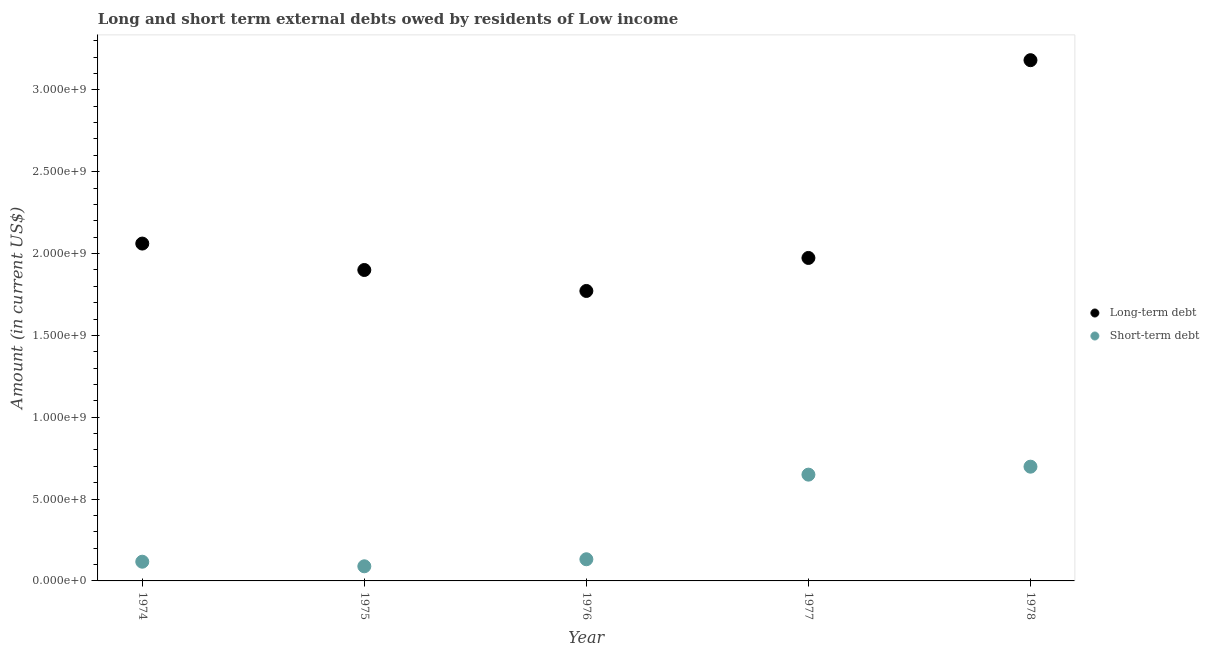How many different coloured dotlines are there?
Make the answer very short. 2. What is the long-term debts owed by residents in 1977?
Offer a terse response. 1.97e+09. Across all years, what is the maximum short-term debts owed by residents?
Your response must be concise. 6.98e+08. Across all years, what is the minimum short-term debts owed by residents?
Your answer should be very brief. 8.94e+07. In which year was the short-term debts owed by residents maximum?
Give a very brief answer. 1978. In which year was the long-term debts owed by residents minimum?
Give a very brief answer. 1976. What is the total short-term debts owed by residents in the graph?
Provide a short and direct response. 1.69e+09. What is the difference between the long-term debts owed by residents in 1976 and that in 1978?
Your answer should be compact. -1.41e+09. What is the difference between the long-term debts owed by residents in 1975 and the short-term debts owed by residents in 1977?
Your answer should be compact. 1.25e+09. What is the average short-term debts owed by residents per year?
Provide a succinct answer. 3.37e+08. In the year 1978, what is the difference between the long-term debts owed by residents and short-term debts owed by residents?
Make the answer very short. 2.48e+09. What is the ratio of the long-term debts owed by residents in 1974 to that in 1975?
Ensure brevity in your answer.  1.08. Is the short-term debts owed by residents in 1974 less than that in 1977?
Ensure brevity in your answer.  Yes. What is the difference between the highest and the second highest short-term debts owed by residents?
Make the answer very short. 4.86e+07. What is the difference between the highest and the lowest short-term debts owed by residents?
Ensure brevity in your answer.  6.09e+08. In how many years, is the short-term debts owed by residents greater than the average short-term debts owed by residents taken over all years?
Ensure brevity in your answer.  2. Is the short-term debts owed by residents strictly greater than the long-term debts owed by residents over the years?
Give a very brief answer. No. How many dotlines are there?
Offer a terse response. 2. How many years are there in the graph?
Offer a very short reply. 5. What is the difference between two consecutive major ticks on the Y-axis?
Your answer should be compact. 5.00e+08. Does the graph contain any zero values?
Offer a terse response. No. Does the graph contain grids?
Keep it short and to the point. No. How many legend labels are there?
Ensure brevity in your answer.  2. How are the legend labels stacked?
Make the answer very short. Vertical. What is the title of the graph?
Make the answer very short. Long and short term external debts owed by residents of Low income. Does "Net savings(excluding particulate emission damage)" appear as one of the legend labels in the graph?
Your answer should be very brief. No. What is the label or title of the Y-axis?
Offer a terse response. Amount (in current US$). What is the Amount (in current US$) of Long-term debt in 1974?
Keep it short and to the point. 2.06e+09. What is the Amount (in current US$) of Short-term debt in 1974?
Make the answer very short. 1.17e+08. What is the Amount (in current US$) of Long-term debt in 1975?
Your response must be concise. 1.90e+09. What is the Amount (in current US$) in Short-term debt in 1975?
Offer a very short reply. 8.94e+07. What is the Amount (in current US$) of Long-term debt in 1976?
Your response must be concise. 1.77e+09. What is the Amount (in current US$) of Short-term debt in 1976?
Provide a short and direct response. 1.32e+08. What is the Amount (in current US$) in Long-term debt in 1977?
Your answer should be very brief. 1.97e+09. What is the Amount (in current US$) in Short-term debt in 1977?
Offer a very short reply. 6.49e+08. What is the Amount (in current US$) of Long-term debt in 1978?
Your answer should be very brief. 3.18e+09. What is the Amount (in current US$) in Short-term debt in 1978?
Offer a very short reply. 6.98e+08. Across all years, what is the maximum Amount (in current US$) of Long-term debt?
Ensure brevity in your answer.  3.18e+09. Across all years, what is the maximum Amount (in current US$) in Short-term debt?
Offer a terse response. 6.98e+08. Across all years, what is the minimum Amount (in current US$) of Long-term debt?
Provide a short and direct response. 1.77e+09. Across all years, what is the minimum Amount (in current US$) in Short-term debt?
Keep it short and to the point. 8.94e+07. What is the total Amount (in current US$) in Long-term debt in the graph?
Keep it short and to the point. 1.09e+1. What is the total Amount (in current US$) in Short-term debt in the graph?
Make the answer very short. 1.69e+09. What is the difference between the Amount (in current US$) in Long-term debt in 1974 and that in 1975?
Make the answer very short. 1.61e+08. What is the difference between the Amount (in current US$) of Short-term debt in 1974 and that in 1975?
Provide a succinct answer. 2.80e+07. What is the difference between the Amount (in current US$) of Long-term debt in 1974 and that in 1976?
Your answer should be very brief. 2.90e+08. What is the difference between the Amount (in current US$) of Short-term debt in 1974 and that in 1976?
Ensure brevity in your answer.  -1.50e+07. What is the difference between the Amount (in current US$) in Long-term debt in 1974 and that in 1977?
Ensure brevity in your answer.  8.79e+07. What is the difference between the Amount (in current US$) of Short-term debt in 1974 and that in 1977?
Provide a short and direct response. -5.32e+08. What is the difference between the Amount (in current US$) of Long-term debt in 1974 and that in 1978?
Give a very brief answer. -1.12e+09. What is the difference between the Amount (in current US$) in Short-term debt in 1974 and that in 1978?
Keep it short and to the point. -5.81e+08. What is the difference between the Amount (in current US$) of Long-term debt in 1975 and that in 1976?
Your response must be concise. 1.28e+08. What is the difference between the Amount (in current US$) of Short-term debt in 1975 and that in 1976?
Your answer should be very brief. -4.30e+07. What is the difference between the Amount (in current US$) of Long-term debt in 1975 and that in 1977?
Your answer should be very brief. -7.36e+07. What is the difference between the Amount (in current US$) of Short-term debt in 1975 and that in 1977?
Provide a succinct answer. -5.60e+08. What is the difference between the Amount (in current US$) of Long-term debt in 1975 and that in 1978?
Ensure brevity in your answer.  -1.28e+09. What is the difference between the Amount (in current US$) in Short-term debt in 1975 and that in 1978?
Offer a terse response. -6.09e+08. What is the difference between the Amount (in current US$) of Long-term debt in 1976 and that in 1977?
Offer a very short reply. -2.02e+08. What is the difference between the Amount (in current US$) of Short-term debt in 1976 and that in 1977?
Keep it short and to the point. -5.17e+08. What is the difference between the Amount (in current US$) in Long-term debt in 1976 and that in 1978?
Make the answer very short. -1.41e+09. What is the difference between the Amount (in current US$) of Short-term debt in 1976 and that in 1978?
Provide a succinct answer. -5.66e+08. What is the difference between the Amount (in current US$) in Long-term debt in 1977 and that in 1978?
Keep it short and to the point. -1.21e+09. What is the difference between the Amount (in current US$) of Short-term debt in 1977 and that in 1978?
Offer a terse response. -4.86e+07. What is the difference between the Amount (in current US$) in Long-term debt in 1974 and the Amount (in current US$) in Short-term debt in 1975?
Offer a very short reply. 1.97e+09. What is the difference between the Amount (in current US$) in Long-term debt in 1974 and the Amount (in current US$) in Short-term debt in 1976?
Offer a very short reply. 1.93e+09. What is the difference between the Amount (in current US$) of Long-term debt in 1974 and the Amount (in current US$) of Short-term debt in 1977?
Your response must be concise. 1.41e+09. What is the difference between the Amount (in current US$) of Long-term debt in 1974 and the Amount (in current US$) of Short-term debt in 1978?
Offer a terse response. 1.36e+09. What is the difference between the Amount (in current US$) in Long-term debt in 1975 and the Amount (in current US$) in Short-term debt in 1976?
Offer a very short reply. 1.77e+09. What is the difference between the Amount (in current US$) in Long-term debt in 1975 and the Amount (in current US$) in Short-term debt in 1977?
Your answer should be compact. 1.25e+09. What is the difference between the Amount (in current US$) of Long-term debt in 1975 and the Amount (in current US$) of Short-term debt in 1978?
Ensure brevity in your answer.  1.20e+09. What is the difference between the Amount (in current US$) of Long-term debt in 1976 and the Amount (in current US$) of Short-term debt in 1977?
Give a very brief answer. 1.12e+09. What is the difference between the Amount (in current US$) of Long-term debt in 1976 and the Amount (in current US$) of Short-term debt in 1978?
Provide a short and direct response. 1.07e+09. What is the difference between the Amount (in current US$) of Long-term debt in 1977 and the Amount (in current US$) of Short-term debt in 1978?
Ensure brevity in your answer.  1.28e+09. What is the average Amount (in current US$) in Long-term debt per year?
Give a very brief answer. 2.18e+09. What is the average Amount (in current US$) in Short-term debt per year?
Offer a terse response. 3.37e+08. In the year 1974, what is the difference between the Amount (in current US$) in Long-term debt and Amount (in current US$) in Short-term debt?
Your answer should be compact. 1.94e+09. In the year 1975, what is the difference between the Amount (in current US$) in Long-term debt and Amount (in current US$) in Short-term debt?
Your answer should be compact. 1.81e+09. In the year 1976, what is the difference between the Amount (in current US$) of Long-term debt and Amount (in current US$) of Short-term debt?
Make the answer very short. 1.64e+09. In the year 1977, what is the difference between the Amount (in current US$) of Long-term debt and Amount (in current US$) of Short-term debt?
Make the answer very short. 1.32e+09. In the year 1978, what is the difference between the Amount (in current US$) of Long-term debt and Amount (in current US$) of Short-term debt?
Keep it short and to the point. 2.48e+09. What is the ratio of the Amount (in current US$) in Long-term debt in 1974 to that in 1975?
Your response must be concise. 1.08. What is the ratio of the Amount (in current US$) in Short-term debt in 1974 to that in 1975?
Offer a terse response. 1.31. What is the ratio of the Amount (in current US$) in Long-term debt in 1974 to that in 1976?
Ensure brevity in your answer.  1.16. What is the ratio of the Amount (in current US$) in Short-term debt in 1974 to that in 1976?
Provide a succinct answer. 0.89. What is the ratio of the Amount (in current US$) in Long-term debt in 1974 to that in 1977?
Offer a very short reply. 1.04. What is the ratio of the Amount (in current US$) of Short-term debt in 1974 to that in 1977?
Your answer should be compact. 0.18. What is the ratio of the Amount (in current US$) in Long-term debt in 1974 to that in 1978?
Your answer should be very brief. 0.65. What is the ratio of the Amount (in current US$) of Short-term debt in 1974 to that in 1978?
Offer a very short reply. 0.17. What is the ratio of the Amount (in current US$) of Long-term debt in 1975 to that in 1976?
Your response must be concise. 1.07. What is the ratio of the Amount (in current US$) of Short-term debt in 1975 to that in 1976?
Make the answer very short. 0.68. What is the ratio of the Amount (in current US$) of Long-term debt in 1975 to that in 1977?
Give a very brief answer. 0.96. What is the ratio of the Amount (in current US$) in Short-term debt in 1975 to that in 1977?
Offer a very short reply. 0.14. What is the ratio of the Amount (in current US$) of Long-term debt in 1975 to that in 1978?
Your answer should be very brief. 0.6. What is the ratio of the Amount (in current US$) of Short-term debt in 1975 to that in 1978?
Make the answer very short. 0.13. What is the ratio of the Amount (in current US$) of Long-term debt in 1976 to that in 1977?
Your answer should be compact. 0.9. What is the ratio of the Amount (in current US$) in Short-term debt in 1976 to that in 1977?
Offer a very short reply. 0.2. What is the ratio of the Amount (in current US$) in Long-term debt in 1976 to that in 1978?
Offer a terse response. 0.56. What is the ratio of the Amount (in current US$) of Short-term debt in 1976 to that in 1978?
Offer a very short reply. 0.19. What is the ratio of the Amount (in current US$) in Long-term debt in 1977 to that in 1978?
Offer a terse response. 0.62. What is the ratio of the Amount (in current US$) of Short-term debt in 1977 to that in 1978?
Ensure brevity in your answer.  0.93. What is the difference between the highest and the second highest Amount (in current US$) of Long-term debt?
Your answer should be compact. 1.12e+09. What is the difference between the highest and the second highest Amount (in current US$) in Short-term debt?
Provide a succinct answer. 4.86e+07. What is the difference between the highest and the lowest Amount (in current US$) in Long-term debt?
Make the answer very short. 1.41e+09. What is the difference between the highest and the lowest Amount (in current US$) of Short-term debt?
Provide a short and direct response. 6.09e+08. 